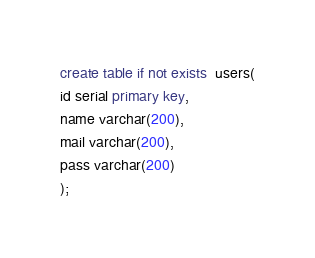Convert code to text. <code><loc_0><loc_0><loc_500><loc_500><_SQL_>create table if not exists  users(
id serial primary key,
name varchar(200),
mail varchar(200),
pass varchar(200)
);
</code> 